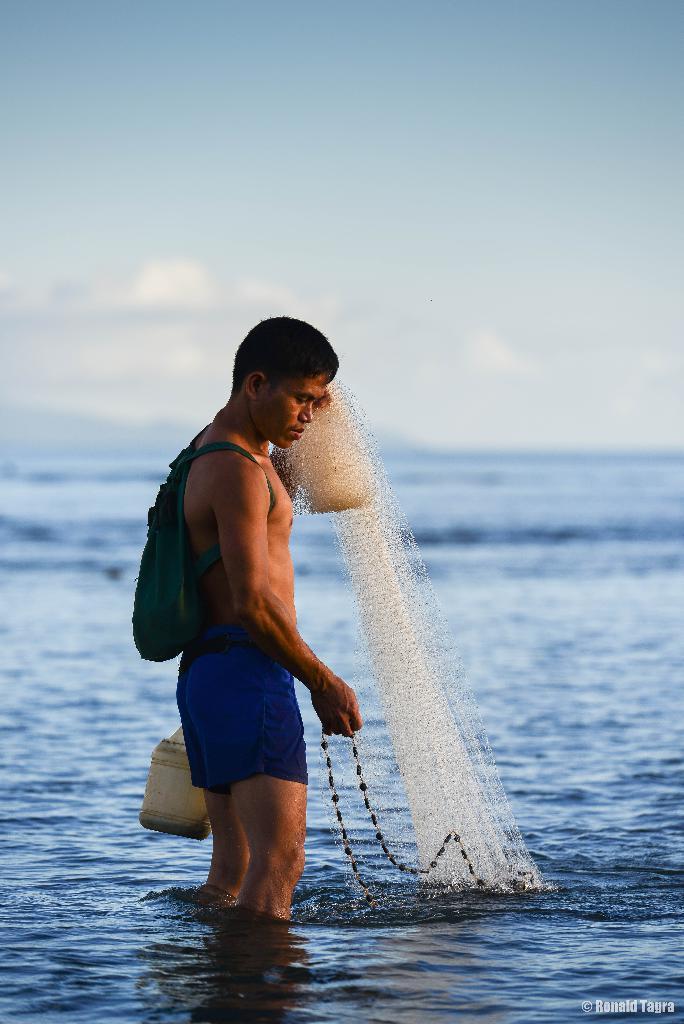Could you give a brief overview of what you see in this image? In this image, in the middle, we can see a man wearing a backpack and holding a net in one hand and some chain in other hand and the man is standing on the water. At the top, we can see a sky, at the bottom, we can see a water in a ocean. 